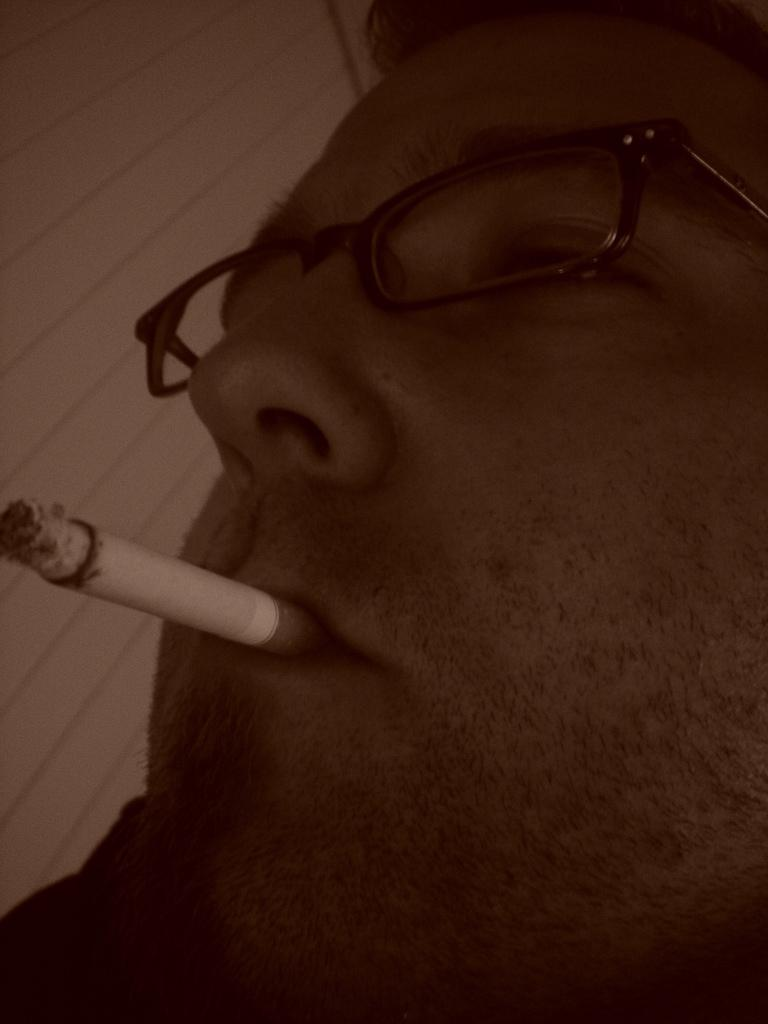What is present in the image? There is a person in the image. What is the person doing in the image? The person is smoking. How many cherries are on the sand in the image? There are no cherries or sand present in the image; it only features a person smoking. 